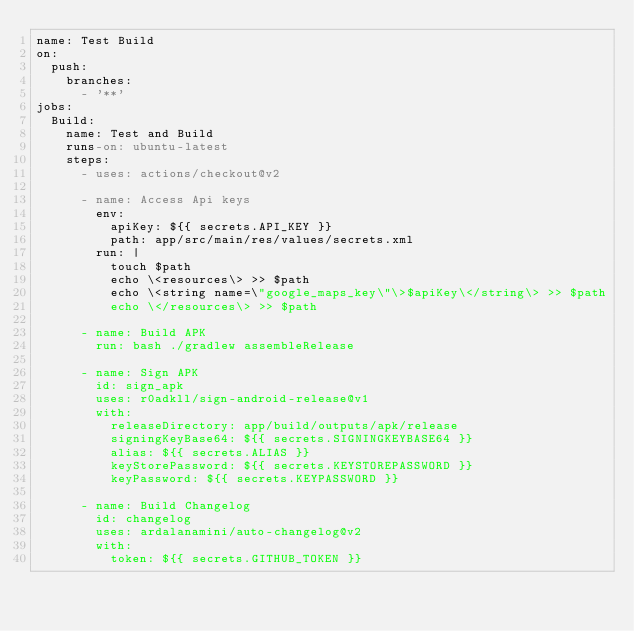Convert code to text. <code><loc_0><loc_0><loc_500><loc_500><_YAML_>name: Test Build
on:
  push:
    branches:
      - '**'
jobs:
  Build:
    name: Test and Build
    runs-on: ubuntu-latest
    steps:
      - uses: actions/checkout@v2

      - name: Access Api keys
        env:
          apiKey: ${{ secrets.API_KEY }}
          path: app/src/main/res/values/secrets.xml
        run: |
          touch $path
          echo \<resources\> >> $path
          echo \<string name=\"google_maps_key\"\>$apiKey\</string\> >> $path
          echo \</resources\> >> $path

      - name: Build APK
        run: bash ./gradlew assembleRelease

      - name: Sign APK
        id: sign_apk
        uses: r0adkll/sign-android-release@v1
        with:
          releaseDirectory: app/build/outputs/apk/release
          signingKeyBase64: ${{ secrets.SIGNINGKEYBASE64 }}
          alias: ${{ secrets.ALIAS }}
          keyStorePassword: ${{ secrets.KEYSTOREPASSWORD }}
          keyPassword: ${{ secrets.KEYPASSWORD }}

      - name: Build Changelog
        id: changelog
        uses: ardalanamini/auto-changelog@v2
        with:
          token: ${{ secrets.GITHUB_TOKEN }}</code> 